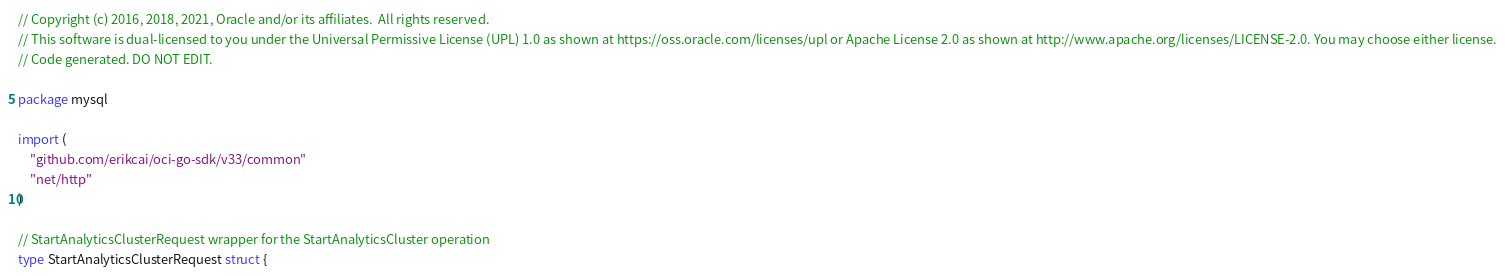Convert code to text. <code><loc_0><loc_0><loc_500><loc_500><_Go_>// Copyright (c) 2016, 2018, 2021, Oracle and/or its affiliates.  All rights reserved.
// This software is dual-licensed to you under the Universal Permissive License (UPL) 1.0 as shown at https://oss.oracle.com/licenses/upl or Apache License 2.0 as shown at http://www.apache.org/licenses/LICENSE-2.0. You may choose either license.
// Code generated. DO NOT EDIT.

package mysql

import (
	"github.com/erikcai/oci-go-sdk/v33/common"
	"net/http"
)

// StartAnalyticsClusterRequest wrapper for the StartAnalyticsCluster operation
type StartAnalyticsClusterRequest struct {
</code> 